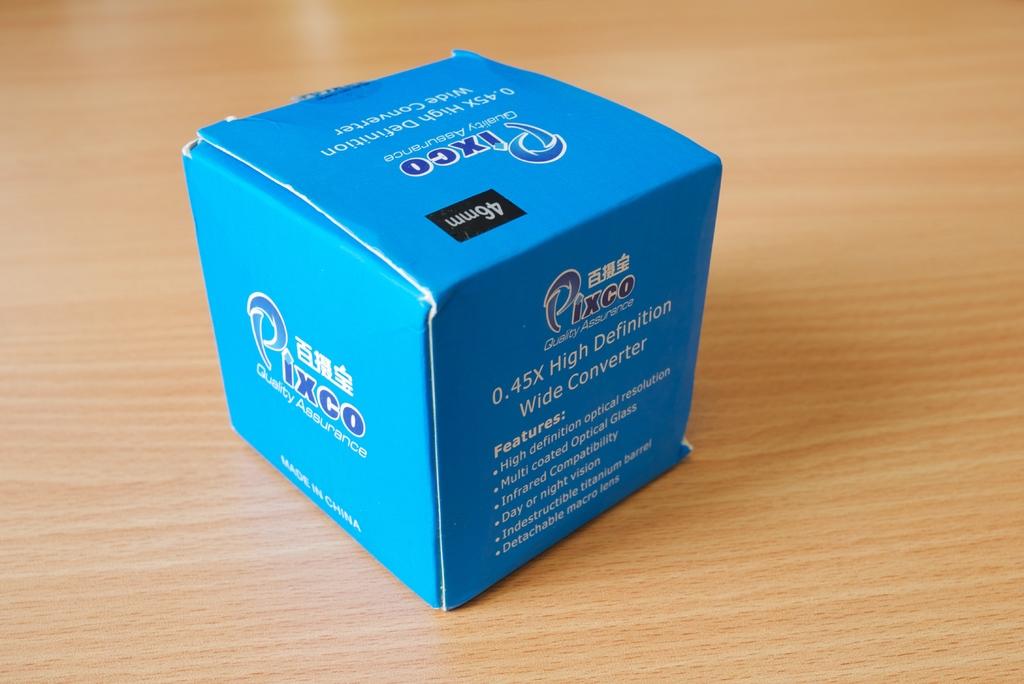Where is the pixco converter made?
Offer a terse response. China. 